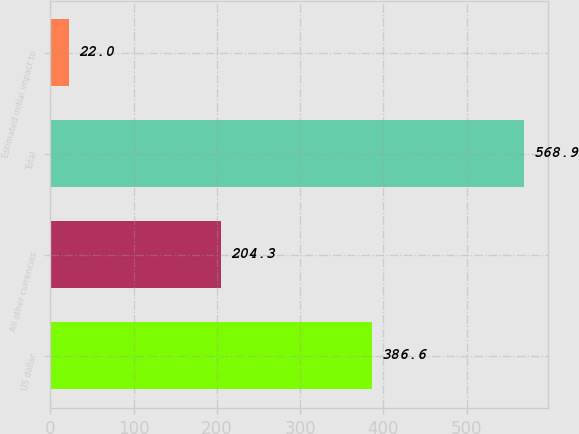<chart> <loc_0><loc_0><loc_500><loc_500><bar_chart><fcel>US dollar<fcel>All other currencies<fcel>Total<fcel>Estimated initial impact to<nl><fcel>386.6<fcel>204.3<fcel>568.9<fcel>22<nl></chart> 